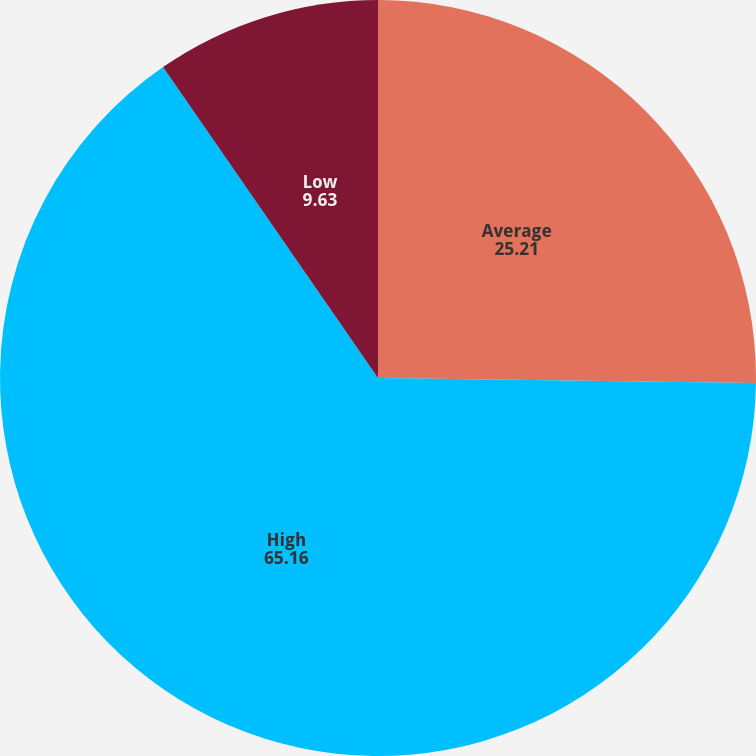Convert chart. <chart><loc_0><loc_0><loc_500><loc_500><pie_chart><fcel>Average<fcel>High<fcel>Low<nl><fcel>25.21%<fcel>65.16%<fcel>9.63%<nl></chart> 